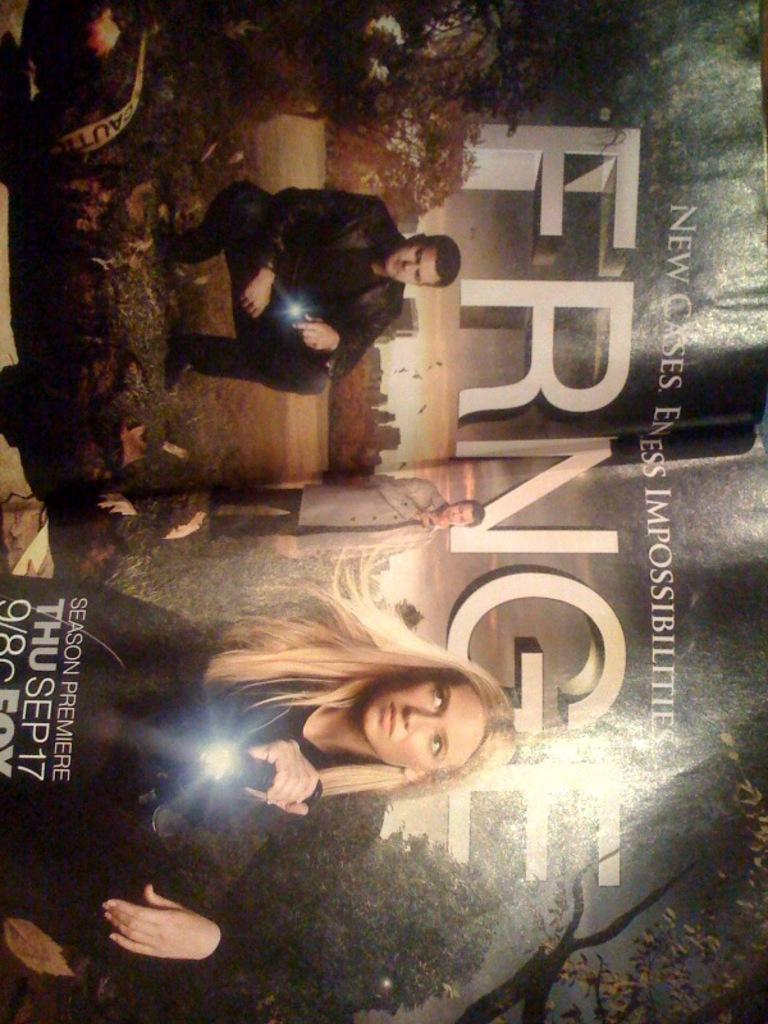<image>
Render a clear and concise summary of the photo. Ad with a man and women for a television show named Fringe. 